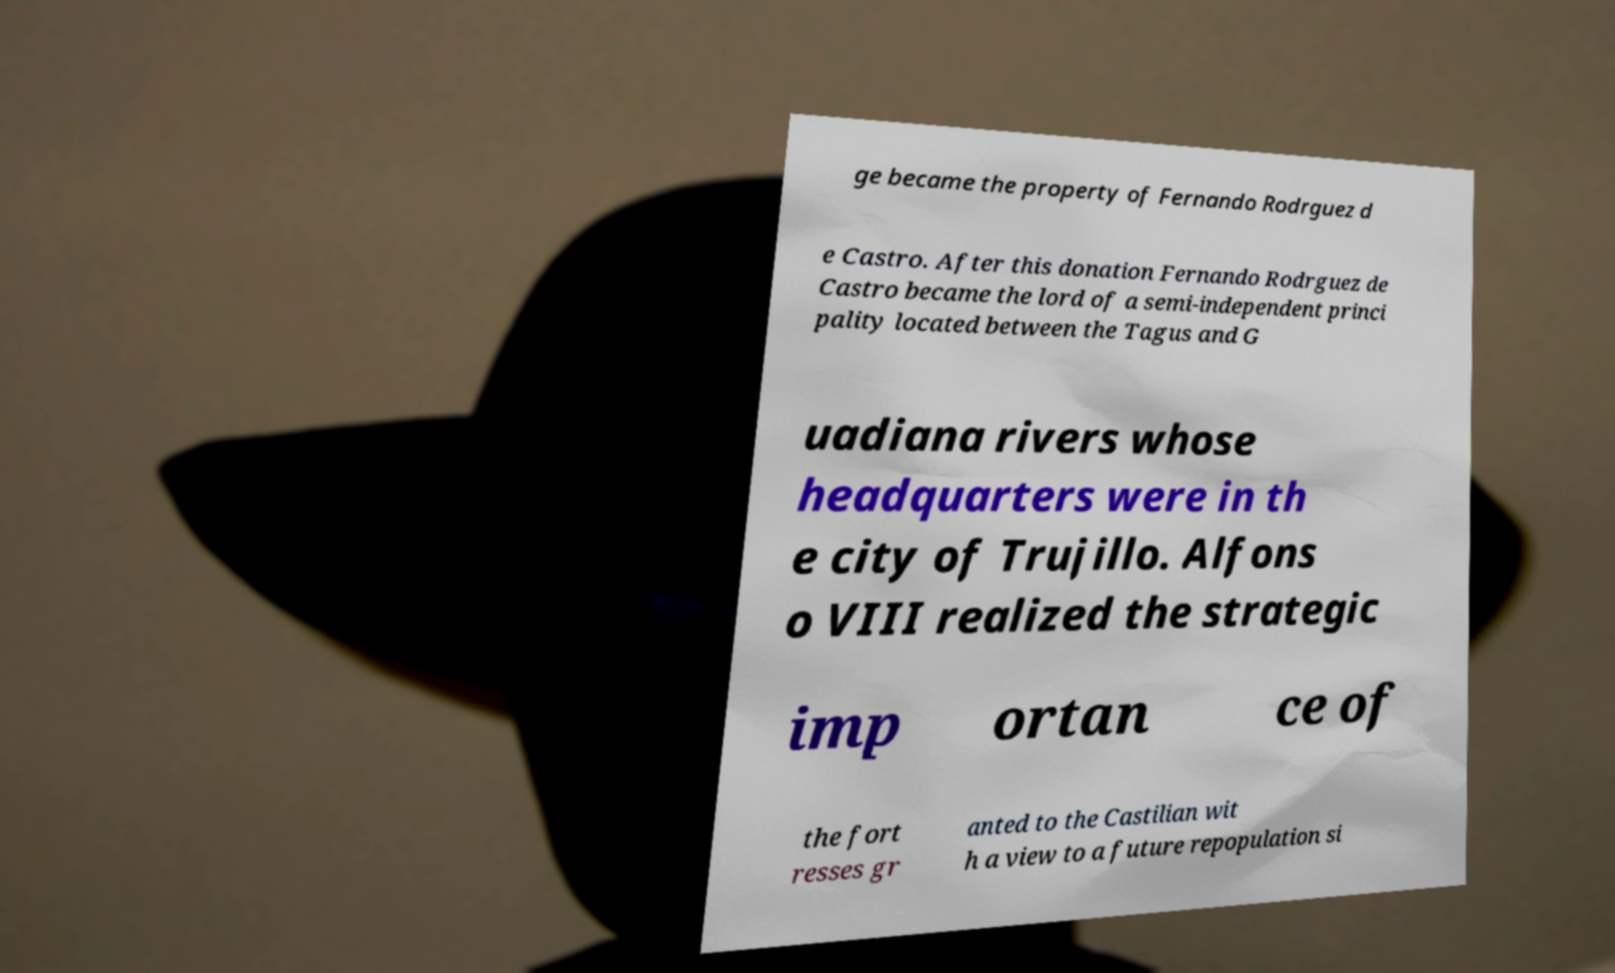Can you read and provide the text displayed in the image?This photo seems to have some interesting text. Can you extract and type it out for me? ge became the property of Fernando Rodrguez d e Castro. After this donation Fernando Rodrguez de Castro became the lord of a semi-independent princi pality located between the Tagus and G uadiana rivers whose headquarters were in th e city of Trujillo. Alfons o VIII realized the strategic imp ortan ce of the fort resses gr anted to the Castilian wit h a view to a future repopulation si 